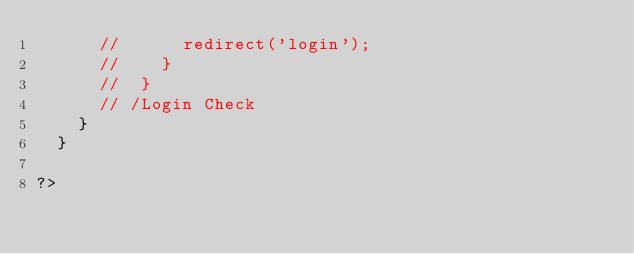<code> <loc_0><loc_0><loc_500><loc_500><_PHP_>			// 			redirect('login');
			// 		}
			// 	}
			// /Login Check
		}
	}

?></code> 